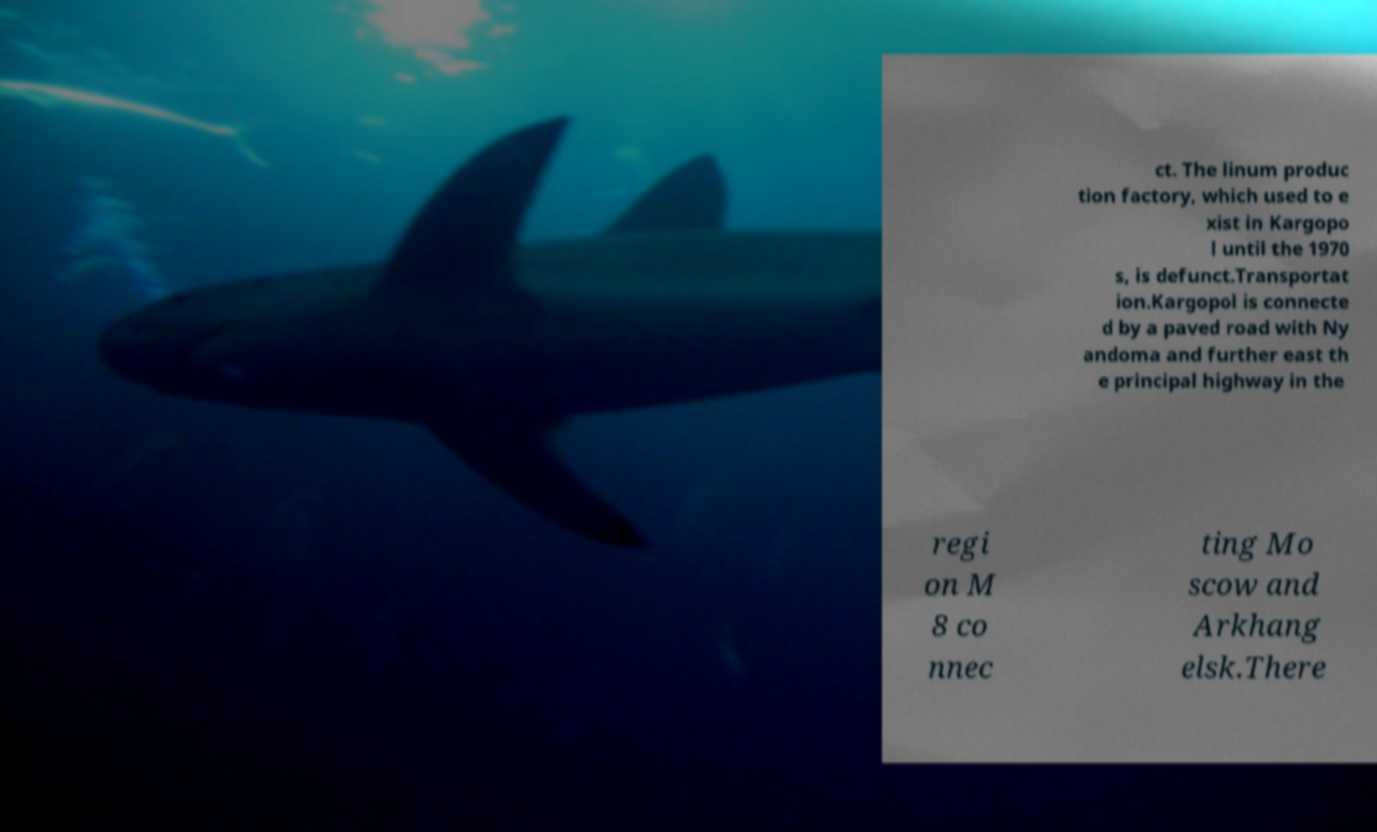For documentation purposes, I need the text within this image transcribed. Could you provide that? ct. The linum produc tion factory, which used to e xist in Kargopo l until the 1970 s, is defunct.Transportat ion.Kargopol is connecte d by a paved road with Ny andoma and further east th e principal highway in the regi on M 8 co nnec ting Mo scow and Arkhang elsk.There 